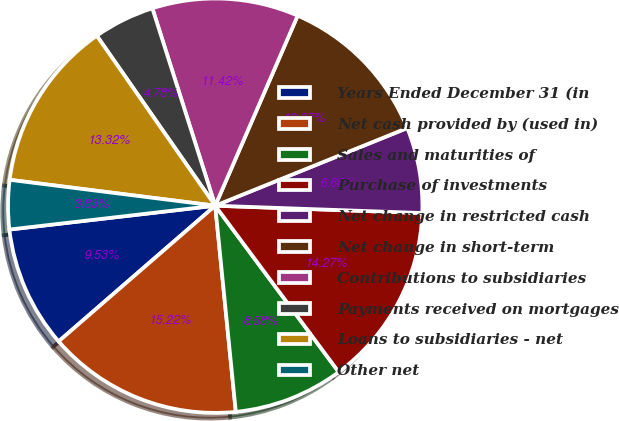Convert chart to OTSL. <chart><loc_0><loc_0><loc_500><loc_500><pie_chart><fcel>Years Ended December 31 (in<fcel>Net cash provided by (used in)<fcel>Sales and maturities of<fcel>Purchase of investments<fcel>Net change in restricted cash<fcel>Net change in short-term<fcel>Contributions to subsidiaries<fcel>Payments received on mortgages<fcel>Loans to subsidiaries - net<fcel>Other net<nl><fcel>9.53%<fcel>15.22%<fcel>8.58%<fcel>14.27%<fcel>6.68%<fcel>12.37%<fcel>11.42%<fcel>4.78%<fcel>13.32%<fcel>3.83%<nl></chart> 